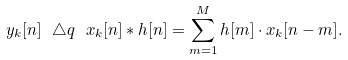Convert formula to latex. <formula><loc_0><loc_0><loc_500><loc_500>y _ { k } [ n ] \ \triangle q \ x _ { k } [ n ] * h [ n ] = \sum _ { m = 1 } ^ { M } h [ m ] \cdot x _ { k } [ n - m ] .</formula> 